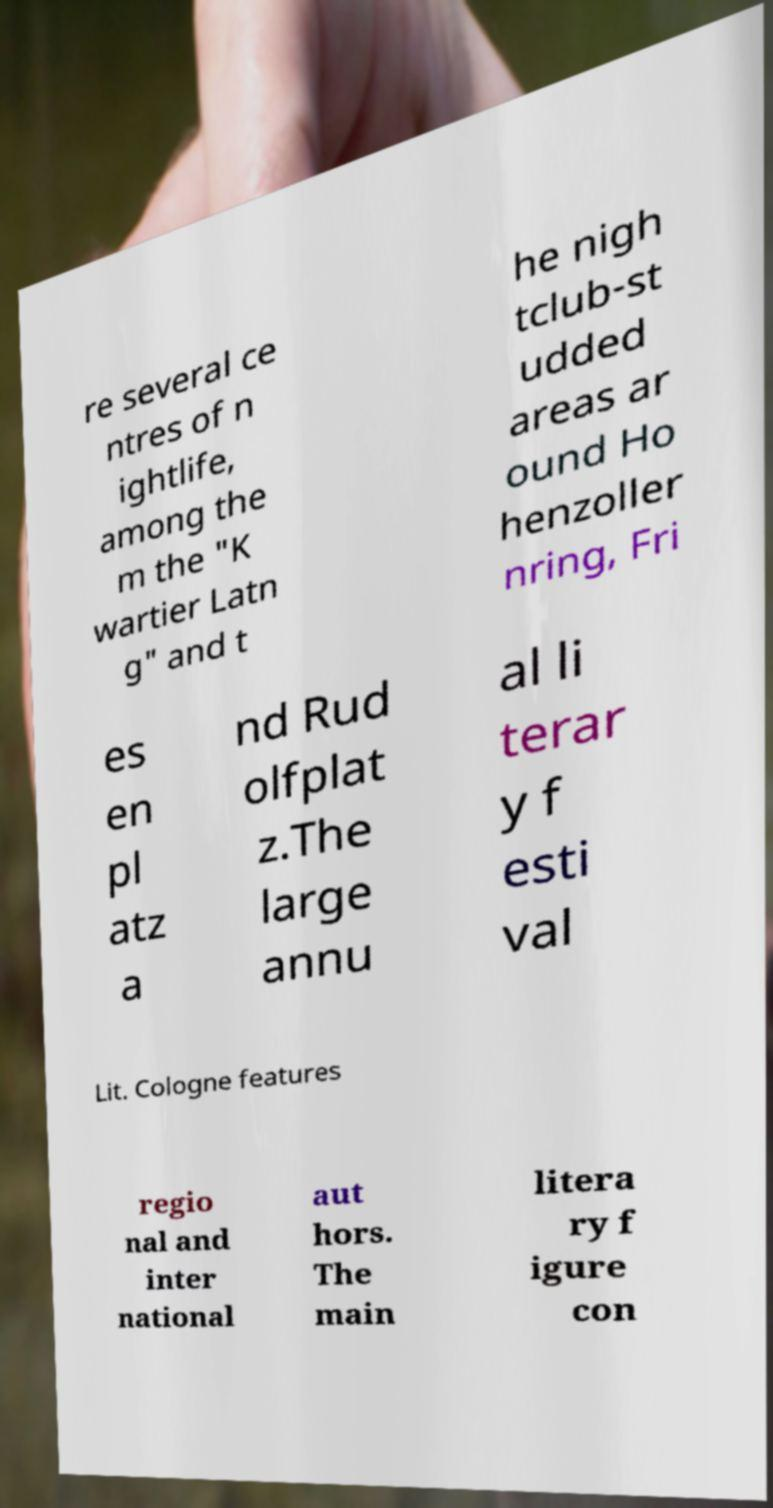There's text embedded in this image that I need extracted. Can you transcribe it verbatim? re several ce ntres of n ightlife, among the m the "K wartier Latn g" and t he nigh tclub-st udded areas ar ound Ho henzoller nring, Fri es en pl atz a nd Rud olfplat z.The large annu al li terar y f esti val Lit. Cologne features regio nal and inter national aut hors. The main litera ry f igure con 